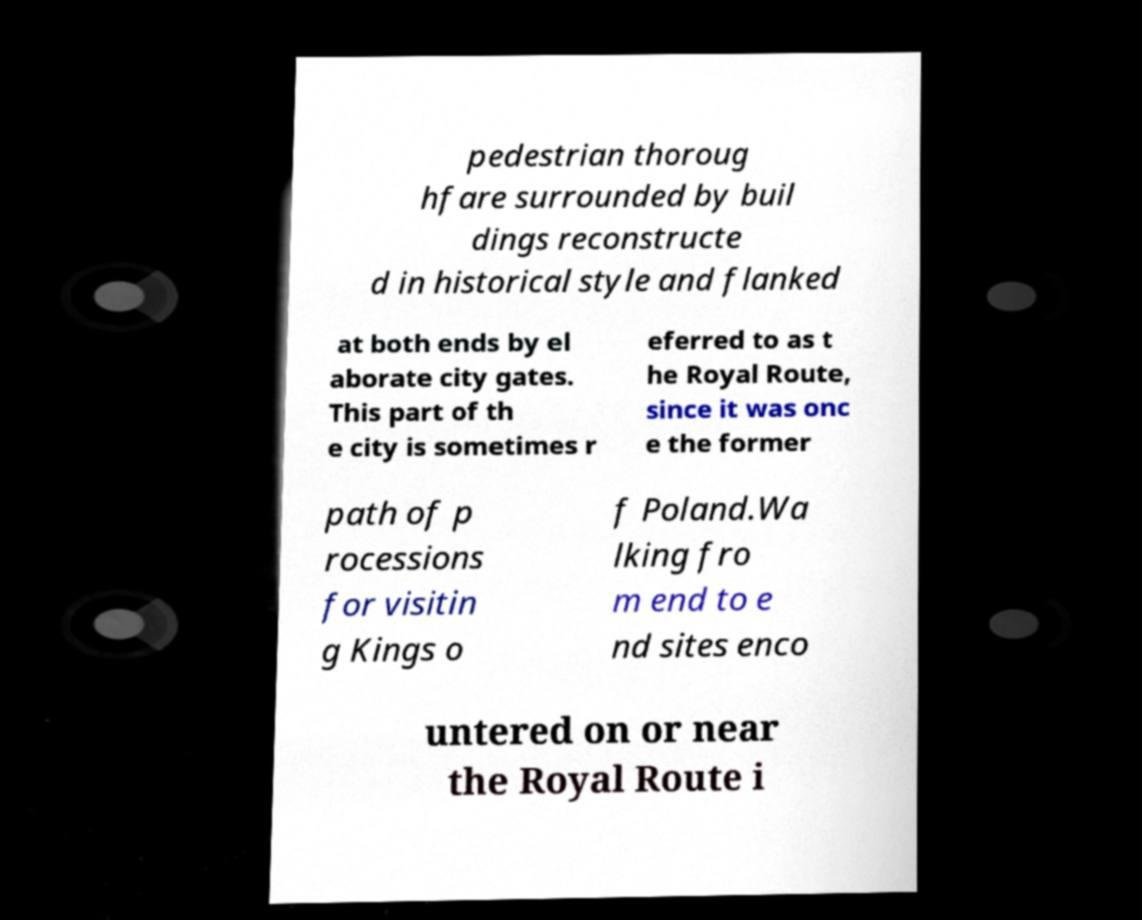Please read and relay the text visible in this image. What does it say? pedestrian thoroug hfare surrounded by buil dings reconstructe d in historical style and flanked at both ends by el aborate city gates. This part of th e city is sometimes r eferred to as t he Royal Route, since it was onc e the former path of p rocessions for visitin g Kings o f Poland.Wa lking fro m end to e nd sites enco untered on or near the Royal Route i 